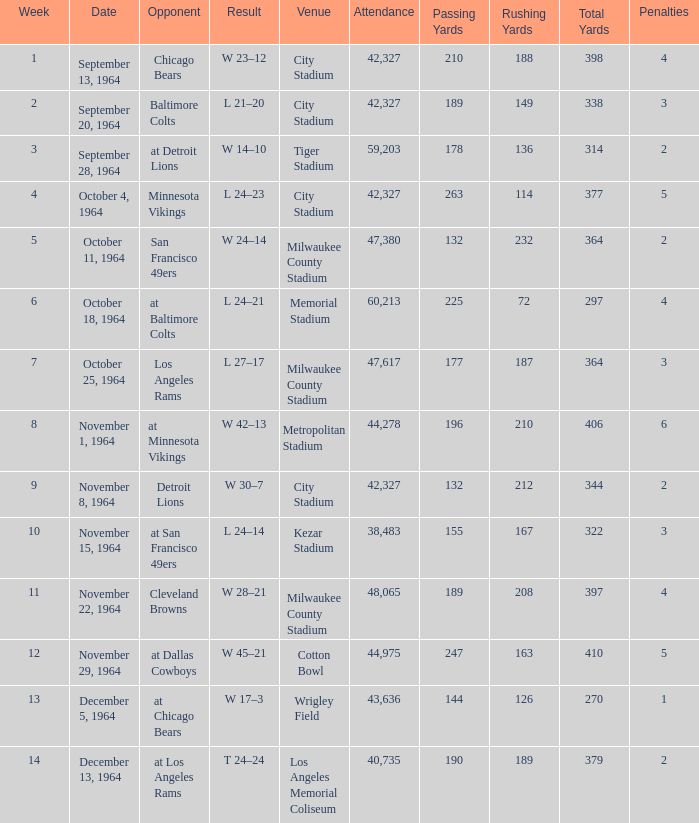Would you be able to parse every entry in this table? {'header': ['Week', 'Date', 'Opponent', 'Result', 'Venue', 'Attendance', 'Passing Yards', 'Rushing Yards', 'Total Yards', 'Penalties'], 'rows': [['1', 'September 13, 1964', 'Chicago Bears', 'W 23–12', 'City Stadium', '42,327', '210', '188', '398', '4'], ['2', 'September 20, 1964', 'Baltimore Colts', 'L 21–20', 'City Stadium', '42,327', '189', '149', '338', '3'], ['3', 'September 28, 1964', 'at Detroit Lions', 'W 14–10', 'Tiger Stadium', '59,203', '178', '136', '314', '2'], ['4', 'October 4, 1964', 'Minnesota Vikings', 'L 24–23', 'City Stadium', '42,327', '263', '114', '377', '5'], ['5', 'October 11, 1964', 'San Francisco 49ers', 'W 24–14', 'Milwaukee County Stadium', '47,380', '132', '232', '364', '2'], ['6', 'October 18, 1964', 'at Baltimore Colts', 'L 24–21', 'Memorial Stadium', '60,213', '225', '72', '297', '4'], ['7', 'October 25, 1964', 'Los Angeles Rams', 'L 27–17', 'Milwaukee County Stadium', '47,617', '177', '187', '364', '3'], ['8', 'November 1, 1964', 'at Minnesota Vikings', 'W 42–13', 'Metropolitan Stadium', '44,278', '196', '210', '406', '6'], ['9', 'November 8, 1964', 'Detroit Lions', 'W 30–7', 'City Stadium', '42,327', '132', '212', '344', '2'], ['10', 'November 15, 1964', 'at San Francisco 49ers', 'L 24–14', 'Kezar Stadium', '38,483', '155', '167', '322', '3'], ['11', 'November 22, 1964', 'Cleveland Browns', 'W 28–21', 'Milwaukee County Stadium', '48,065', '189', '208', '397', '4'], ['12', 'November 29, 1964', 'at Dallas Cowboys', 'W 45–21', 'Cotton Bowl', '44,975', '247', '163', '410', '5'], ['13', 'December 5, 1964', 'at Chicago Bears', 'W 17–3', 'Wrigley Field', '43,636', '144', '126', '270', '1'], ['14', 'December 13, 1964', 'at Los Angeles Rams', 'T 24–24', 'Los Angeles Memorial Coliseum', '40,735', '190', '189', '379', '2']]} In which place was the game with a 24-14 outcome held? Kezar Stadium. 